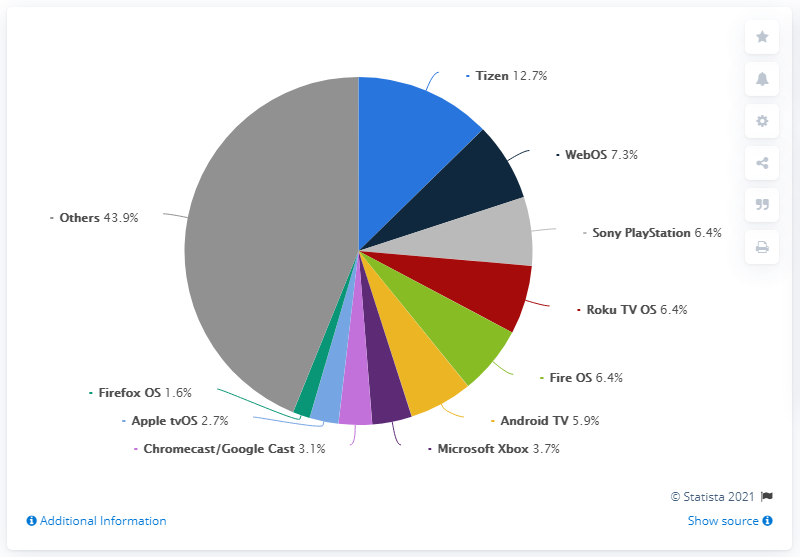List a handful of essential elements in this visual. There are 11 colored segments. Tizen is the leading TV streaming platform worldwide among smart TVs in use. The color of the largest pie is dark gray. 